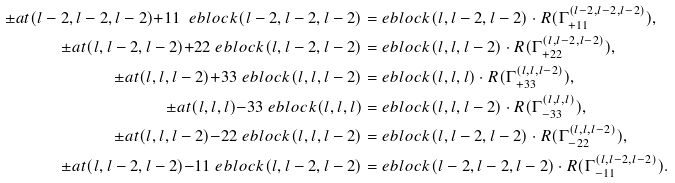Convert formula to latex. <formula><loc_0><loc_0><loc_500><loc_500>\pm a t { ( l - 2 , l - 2 , l - 2 ) } { + } { 1 1 } \ e b l o c k { ( l - 2 , l - 2 , l - 2 ) } = & \ e b l o c k { ( l , l - 2 , l - 2 ) } \cdot R ( \Gamma _ { + 1 1 } ^ { ( l - 2 , l - 2 , l - 2 ) } ) , \\ \pm a t { ( l , l - 2 , l - 2 ) } { + } { 2 2 } \ e b l o c k { ( l , l - 2 , l - 2 ) } = & \ e b l o c k { ( l , l , l - 2 ) } \cdot R ( \Gamma _ { + 2 2 } ^ { ( l , l - 2 , l - 2 ) } ) , \\ \pm a t { ( l , l , l - 2 ) } { + } { 3 3 } \ e b l o c k { ( l , l , l - 2 ) } = & \ e b l o c k { ( l , l , l ) } \cdot R ( \Gamma _ { + 3 3 } ^ { ( l , l , l - 2 ) } ) , \\ \pm a t { ( l , l , l ) } { - } { 3 3 } \ e b l o c k { ( l , l , l ) } = & \ e b l o c k { ( l , l , l - 2 ) } \cdot R ( \Gamma _ { - 3 3 } ^ { ( l , l , l ) } ) , \\ \pm a t { ( l , l , l - 2 ) } { - } { 2 2 } \ e b l o c k { ( l , l , l - 2 ) } = & \ e b l o c k { ( l , l - 2 , l - 2 ) } \cdot R ( \Gamma _ { - 2 2 } ^ { ( l , l , l - 2 ) } ) , \\ \pm a t { ( l , l - 2 , l - 2 ) } { - } { 1 1 } \ e b l o c k { ( l , l - 2 , l - 2 ) } = & \ e b l o c k { ( l - 2 , l - 2 , l - 2 ) } \cdot R ( \Gamma _ { - 1 1 } ^ { ( l , l - 2 , l - 2 ) } ) .</formula> 